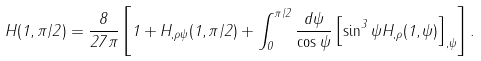<formula> <loc_0><loc_0><loc_500><loc_500>H ( 1 , \pi / 2 ) = \frac { 8 } { 2 7 \pi } \left [ 1 + H _ { , \rho \psi } ( 1 , \pi / 2 ) + \int _ { 0 } ^ { \pi / 2 } \frac { d \psi } { \cos \psi } \left [ \sin ^ { 3 } \psi H _ { , \rho } ( 1 , \psi ) \right ] _ { , \psi } \right ] .</formula> 